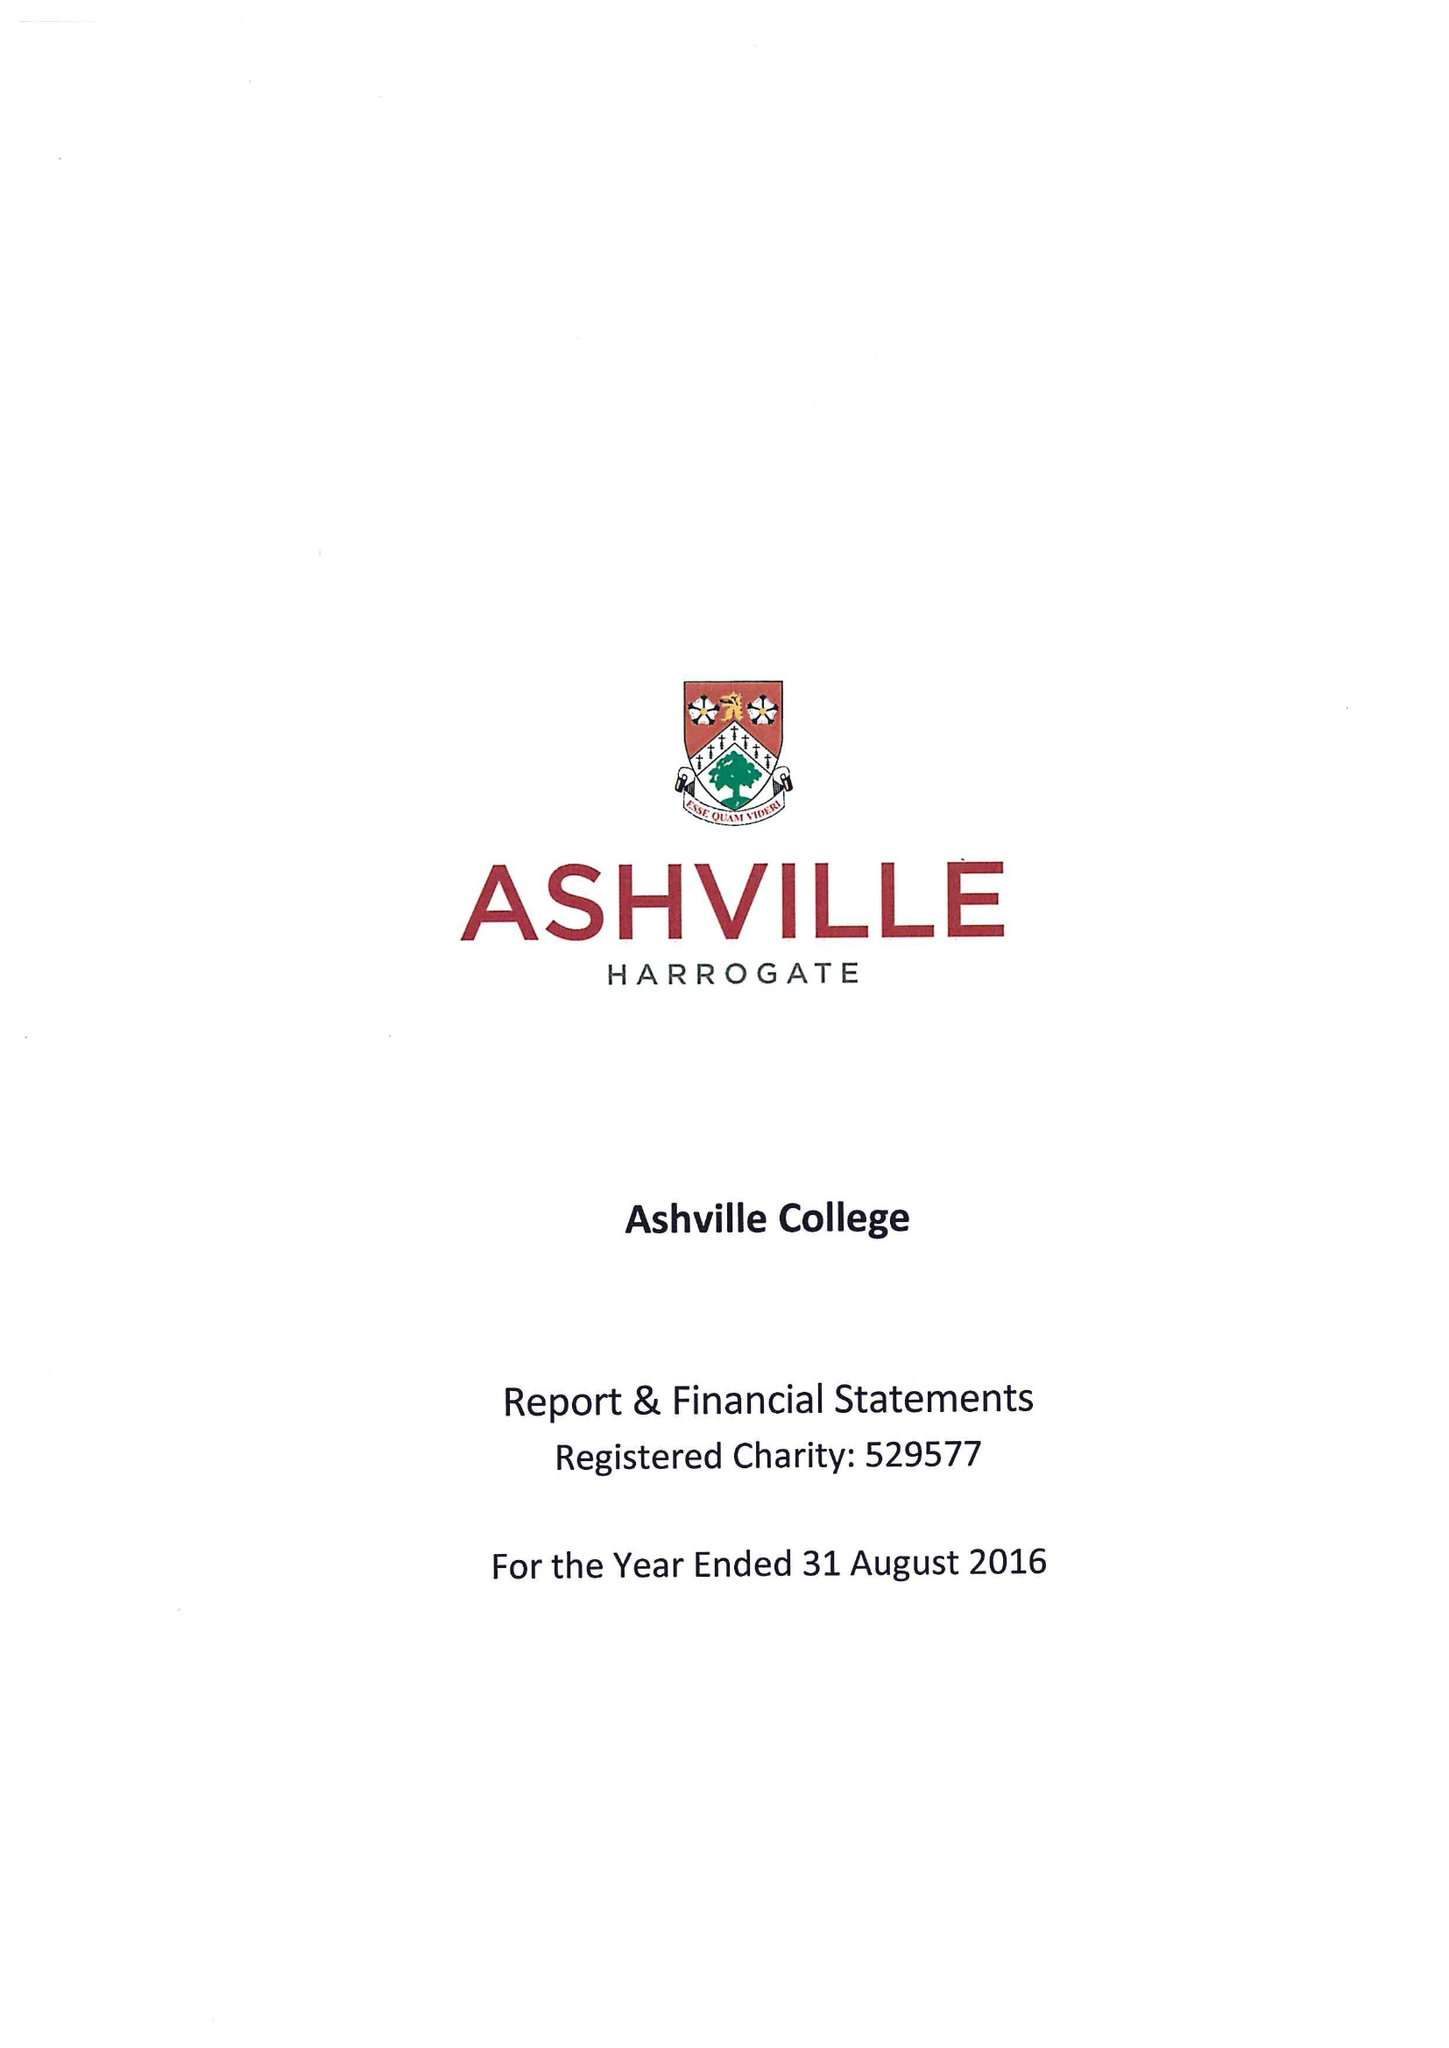What is the value for the address__street_line?
Answer the question using a single word or phrase. GREEN LANE 